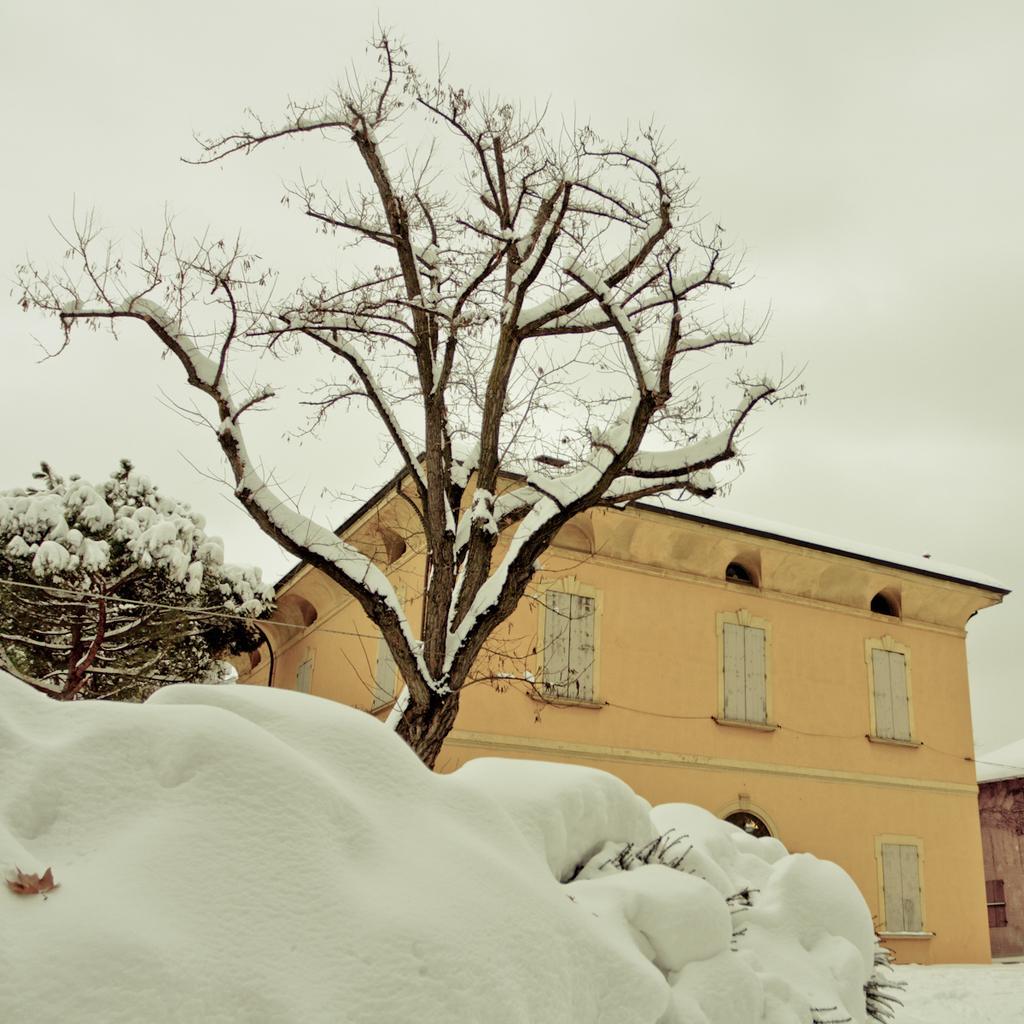In one or two sentences, can you explain what this image depicts? In this image, I can see a house with windows. There are trees and the snow. In the background, I can see the sky. 